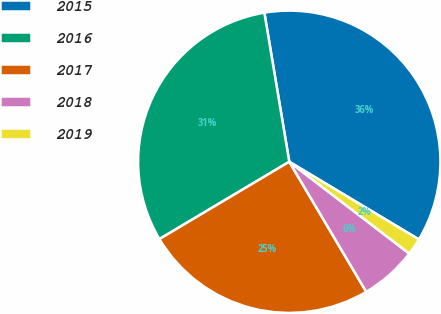<chart> <loc_0><loc_0><loc_500><loc_500><pie_chart><fcel>2015<fcel>2016<fcel>2017<fcel>2018<fcel>2019<nl><fcel>36.23%<fcel>30.91%<fcel>24.96%<fcel>6.1%<fcel>1.8%<nl></chart> 